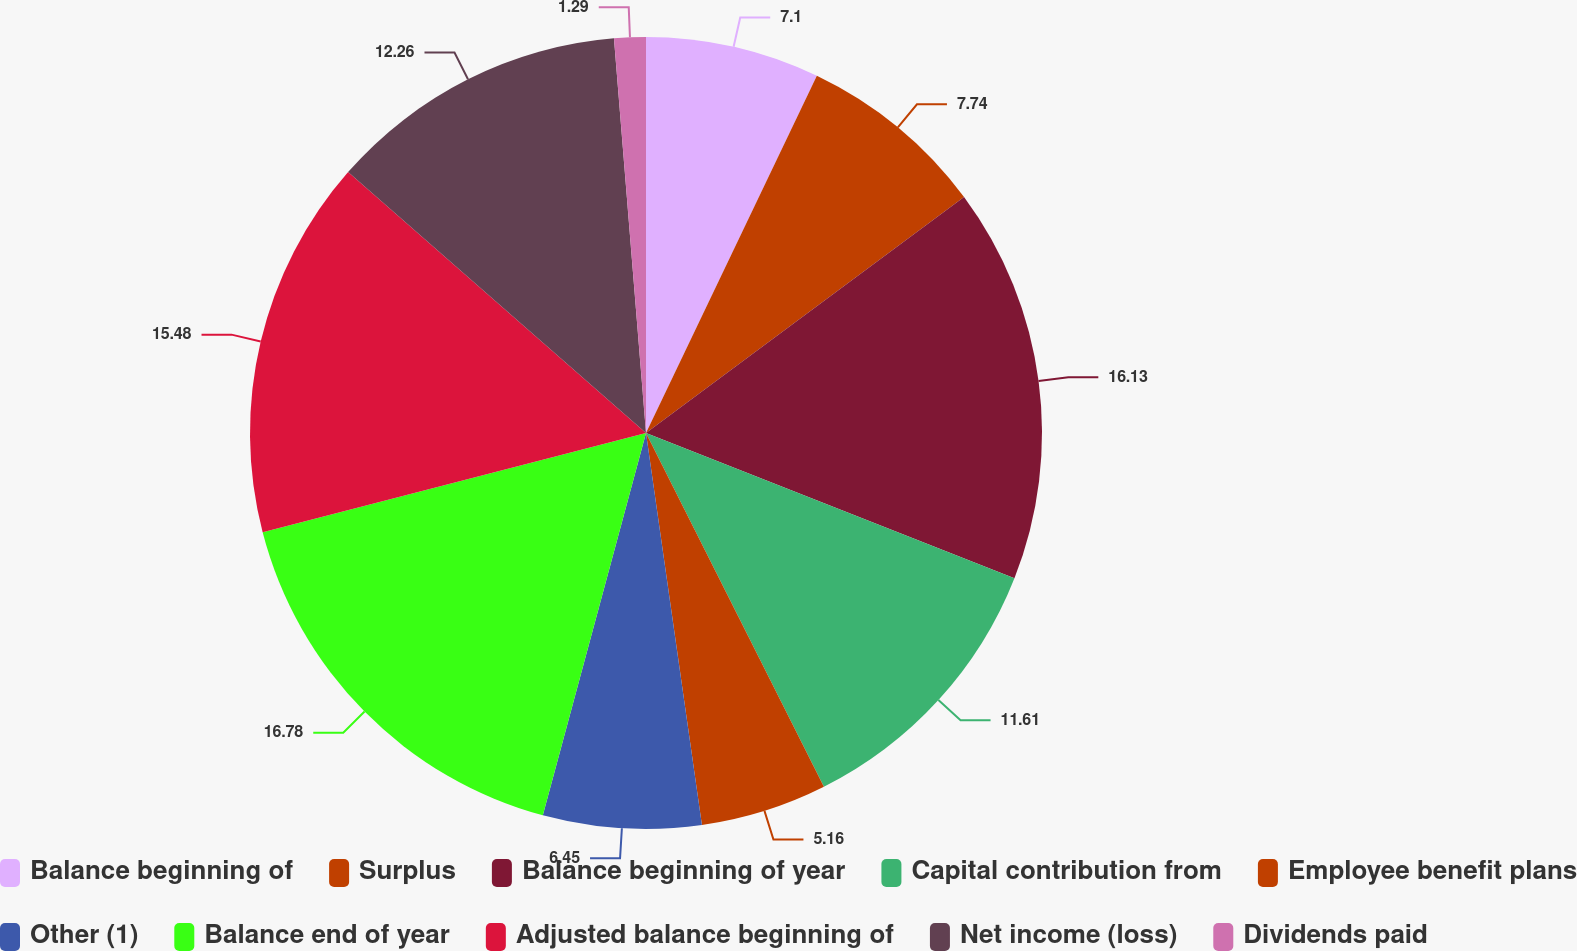<chart> <loc_0><loc_0><loc_500><loc_500><pie_chart><fcel>Balance beginning of<fcel>Surplus<fcel>Balance beginning of year<fcel>Capital contribution from<fcel>Employee benefit plans<fcel>Other (1)<fcel>Balance end of year<fcel>Adjusted balance beginning of<fcel>Net income (loss)<fcel>Dividends paid<nl><fcel>7.1%<fcel>7.74%<fcel>16.13%<fcel>11.61%<fcel>5.16%<fcel>6.45%<fcel>16.77%<fcel>15.48%<fcel>12.26%<fcel>1.29%<nl></chart> 